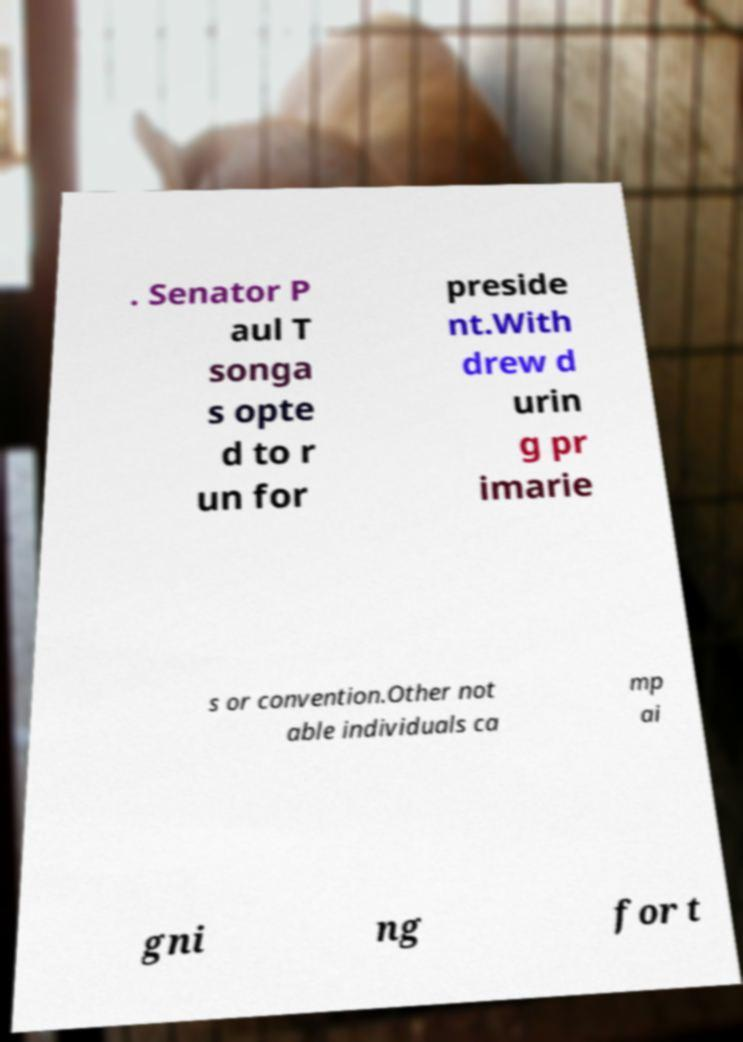Please identify and transcribe the text found in this image. . Senator P aul T songa s opte d to r un for preside nt.With drew d urin g pr imarie s or convention.Other not able individuals ca mp ai gni ng for t 